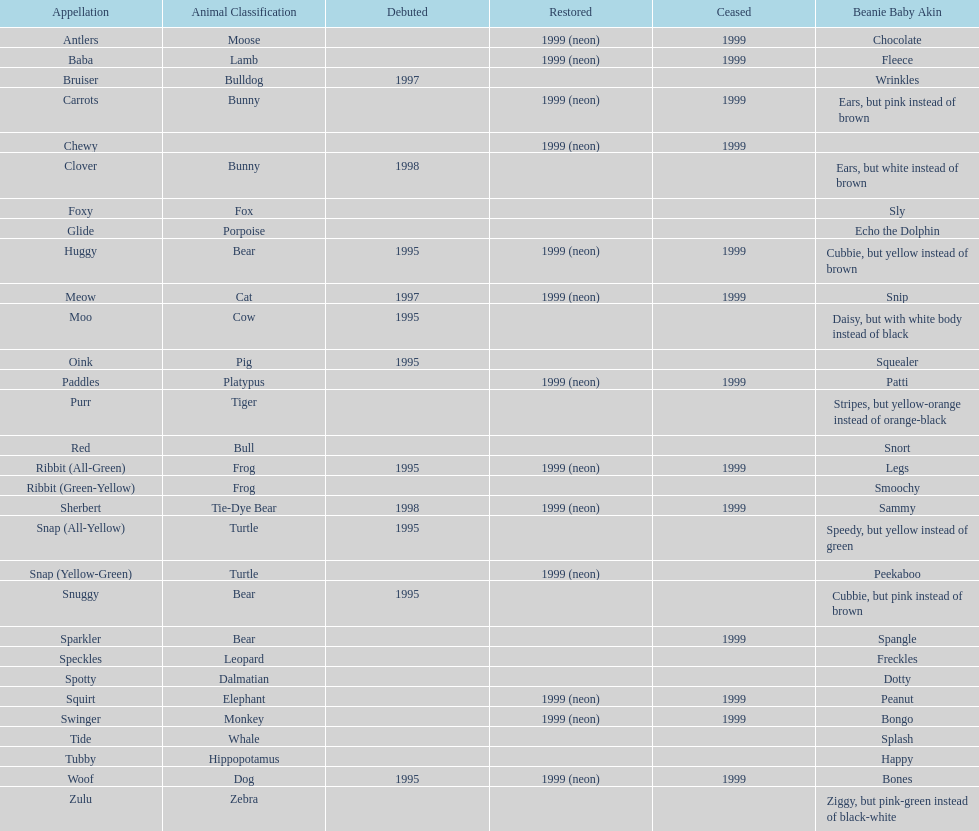How many monkey pillow pals were there? 1. 